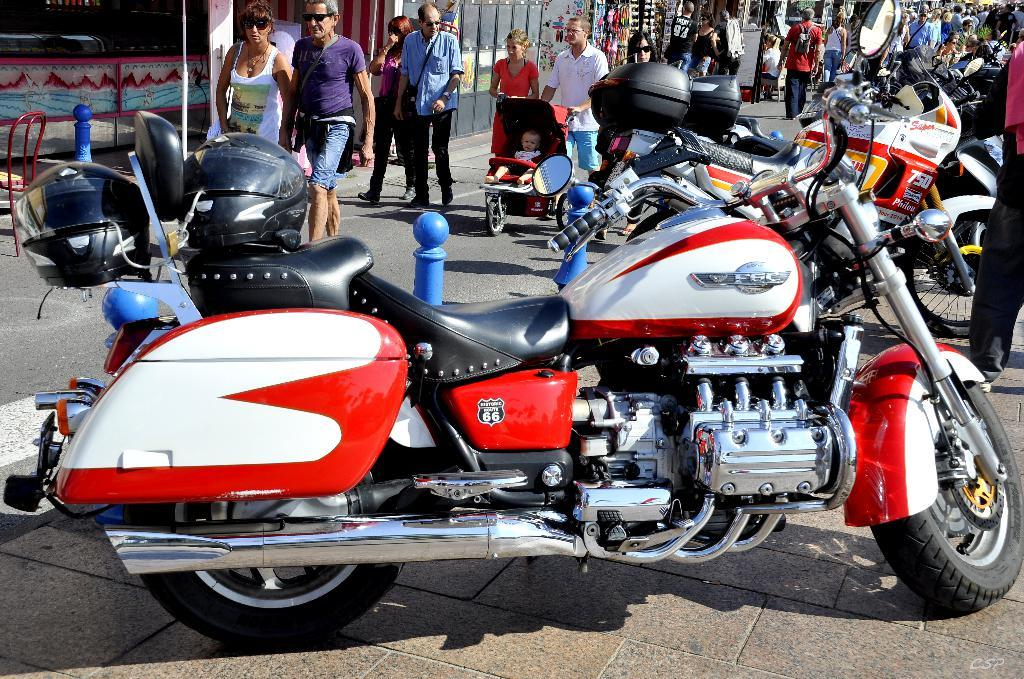<image>
Summarize the visual content of the image. A red motorcycle has the number 66 written on it 